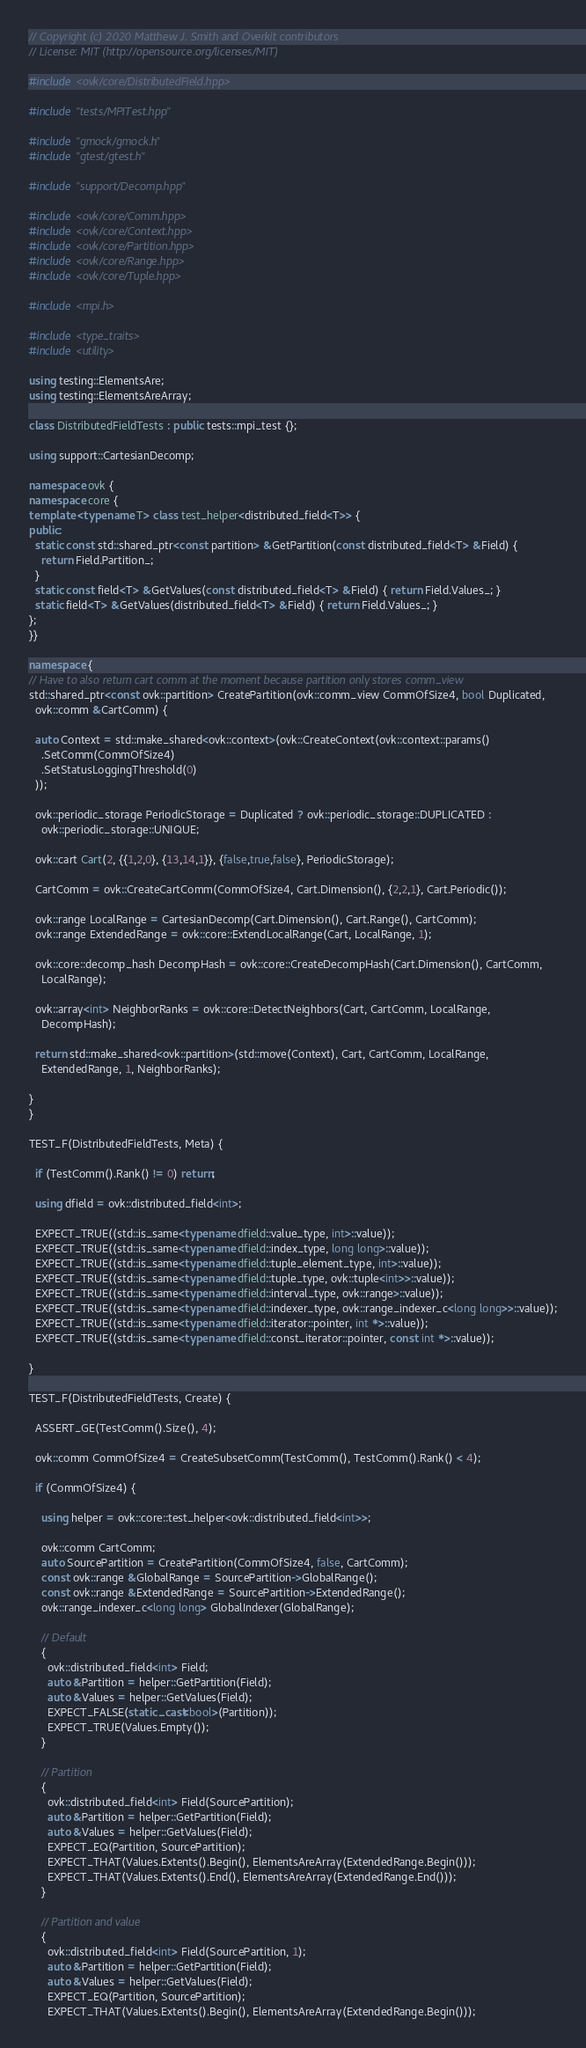Convert code to text. <code><loc_0><loc_0><loc_500><loc_500><_C++_>// Copyright (c) 2020 Matthew J. Smith and Overkit contributors
// License: MIT (http://opensource.org/licenses/MIT)

#include <ovk/core/DistributedField.hpp>

#include "tests/MPITest.hpp"

#include "gmock/gmock.h"
#include "gtest/gtest.h"

#include "support/Decomp.hpp"

#include <ovk/core/Comm.hpp>
#include <ovk/core/Context.hpp>
#include <ovk/core/Partition.hpp>
#include <ovk/core/Range.hpp>
#include <ovk/core/Tuple.hpp>

#include <mpi.h>

#include <type_traits>
#include <utility>

using testing::ElementsAre;
using testing::ElementsAreArray;

class DistributedFieldTests : public tests::mpi_test {};

using support::CartesianDecomp;

namespace ovk {
namespace core {
template <typename T> class test_helper<distributed_field<T>> {
public:
  static const std::shared_ptr<const partition> &GetPartition(const distributed_field<T> &Field) {
    return Field.Partition_;
  }
  static const field<T> &GetValues(const distributed_field<T> &Field) { return Field.Values_; }
  static field<T> &GetValues(distributed_field<T> &Field) { return Field.Values_; }
};
}}

namespace {
// Have to also return cart comm at the moment because partition only stores comm_view
std::shared_ptr<const ovk::partition> CreatePartition(ovk::comm_view CommOfSize4, bool Duplicated,
  ovk::comm &CartComm) {

  auto Context = std::make_shared<ovk::context>(ovk::CreateContext(ovk::context::params()
    .SetComm(CommOfSize4)
    .SetStatusLoggingThreshold(0)
  ));

  ovk::periodic_storage PeriodicStorage = Duplicated ? ovk::periodic_storage::DUPLICATED :
    ovk::periodic_storage::UNIQUE;

  ovk::cart Cart(2, {{1,2,0}, {13,14,1}}, {false,true,false}, PeriodicStorage);

  CartComm = ovk::CreateCartComm(CommOfSize4, Cart.Dimension(), {2,2,1}, Cart.Periodic());

  ovk::range LocalRange = CartesianDecomp(Cart.Dimension(), Cart.Range(), CartComm);
  ovk::range ExtendedRange = ovk::core::ExtendLocalRange(Cart, LocalRange, 1);

  ovk::core::decomp_hash DecompHash = ovk::core::CreateDecompHash(Cart.Dimension(), CartComm,
    LocalRange);

  ovk::array<int> NeighborRanks = ovk::core::DetectNeighbors(Cart, CartComm, LocalRange,
    DecompHash);

  return std::make_shared<ovk::partition>(std::move(Context), Cart, CartComm, LocalRange,
    ExtendedRange, 1, NeighborRanks);

}
}

TEST_F(DistributedFieldTests, Meta) {

  if (TestComm().Rank() != 0) return;

  using dfield = ovk::distributed_field<int>;

  EXPECT_TRUE((std::is_same<typename dfield::value_type, int>::value));
  EXPECT_TRUE((std::is_same<typename dfield::index_type, long long>::value));
  EXPECT_TRUE((std::is_same<typename dfield::tuple_element_type, int>::value));
  EXPECT_TRUE((std::is_same<typename dfield::tuple_type, ovk::tuple<int>>::value));
  EXPECT_TRUE((std::is_same<typename dfield::interval_type, ovk::range>::value));
  EXPECT_TRUE((std::is_same<typename dfield::indexer_type, ovk::range_indexer_c<long long>>::value));
  EXPECT_TRUE((std::is_same<typename dfield::iterator::pointer, int *>::value));
  EXPECT_TRUE((std::is_same<typename dfield::const_iterator::pointer, const int *>::value));

}

TEST_F(DistributedFieldTests, Create) {

  ASSERT_GE(TestComm().Size(), 4);

  ovk::comm CommOfSize4 = CreateSubsetComm(TestComm(), TestComm().Rank() < 4);

  if (CommOfSize4) {

    using helper = ovk::core::test_helper<ovk::distributed_field<int>>;

    ovk::comm CartComm;
    auto SourcePartition = CreatePartition(CommOfSize4, false, CartComm);
    const ovk::range &GlobalRange = SourcePartition->GlobalRange();
    const ovk::range &ExtendedRange = SourcePartition->ExtendedRange();
    ovk::range_indexer_c<long long> GlobalIndexer(GlobalRange);

    // Default
    {
      ovk::distributed_field<int> Field;
      auto &Partition = helper::GetPartition(Field);
      auto &Values = helper::GetValues(Field);
      EXPECT_FALSE(static_cast<bool>(Partition));
      EXPECT_TRUE(Values.Empty());
    }

    // Partition
    {
      ovk::distributed_field<int> Field(SourcePartition);
      auto &Partition = helper::GetPartition(Field);
      auto &Values = helper::GetValues(Field);
      EXPECT_EQ(Partition, SourcePartition);
      EXPECT_THAT(Values.Extents().Begin(), ElementsAreArray(ExtendedRange.Begin()));
      EXPECT_THAT(Values.Extents().End(), ElementsAreArray(ExtendedRange.End()));
    }

    // Partition and value
    {
      ovk::distributed_field<int> Field(SourcePartition, 1);
      auto &Partition = helper::GetPartition(Field);
      auto &Values = helper::GetValues(Field);
      EXPECT_EQ(Partition, SourcePartition);
      EXPECT_THAT(Values.Extents().Begin(), ElementsAreArray(ExtendedRange.Begin()));</code> 